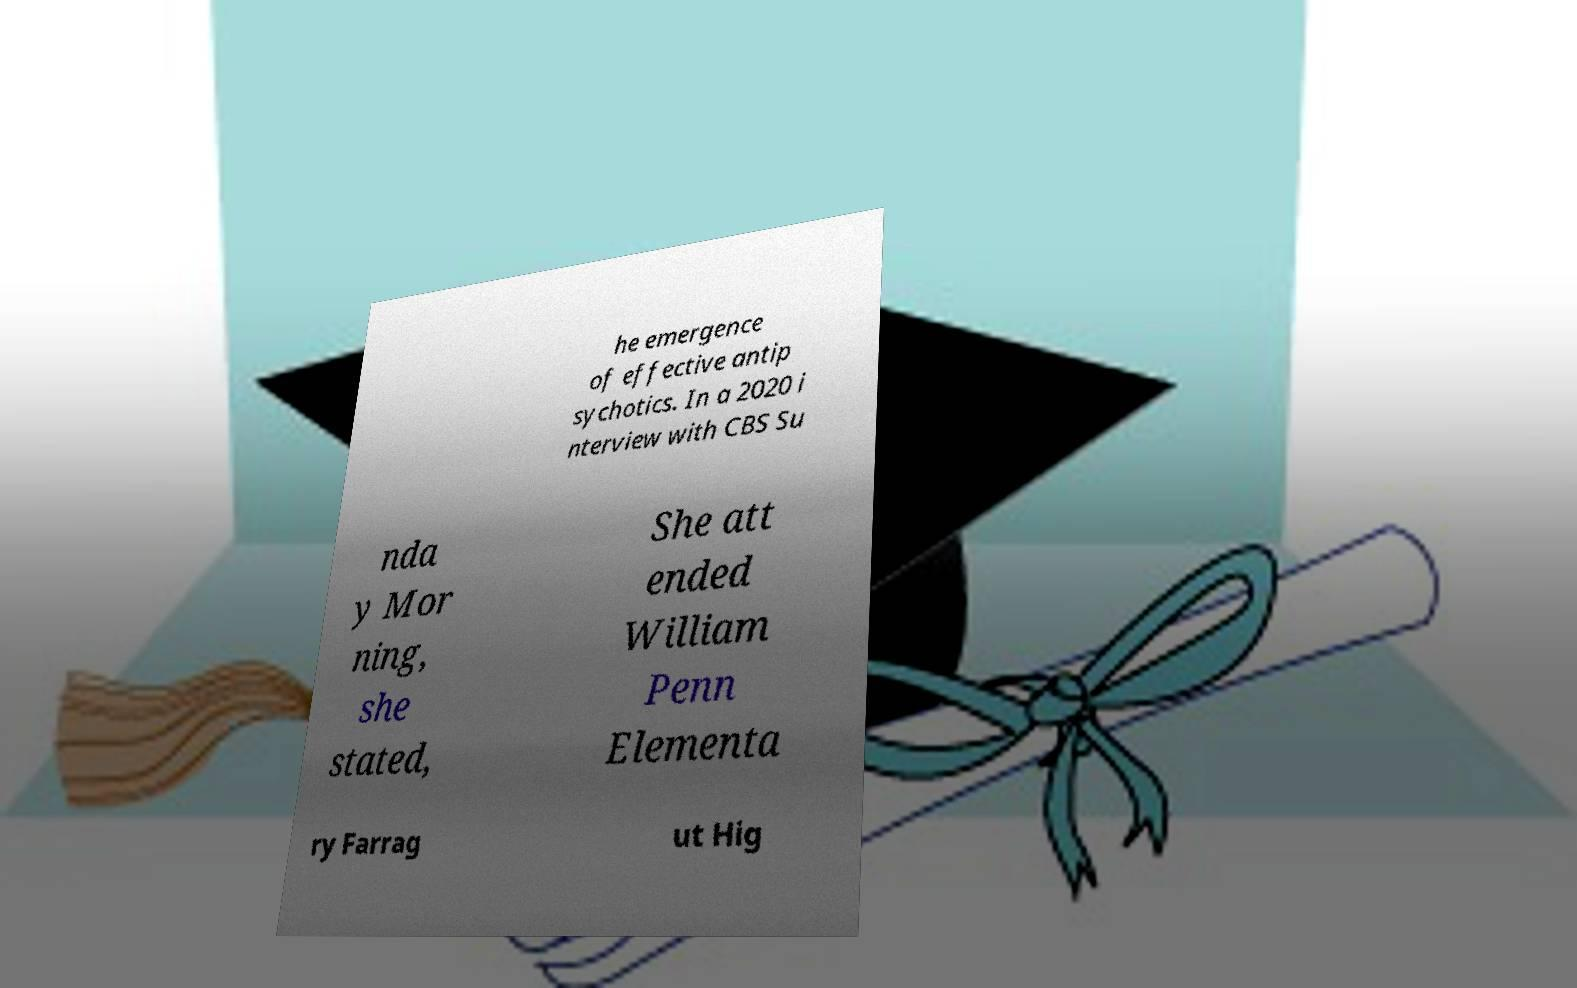Could you assist in decoding the text presented in this image and type it out clearly? he emergence of effective antip sychotics. In a 2020 i nterview with CBS Su nda y Mor ning, she stated, She att ended William Penn Elementa ry Farrag ut Hig 